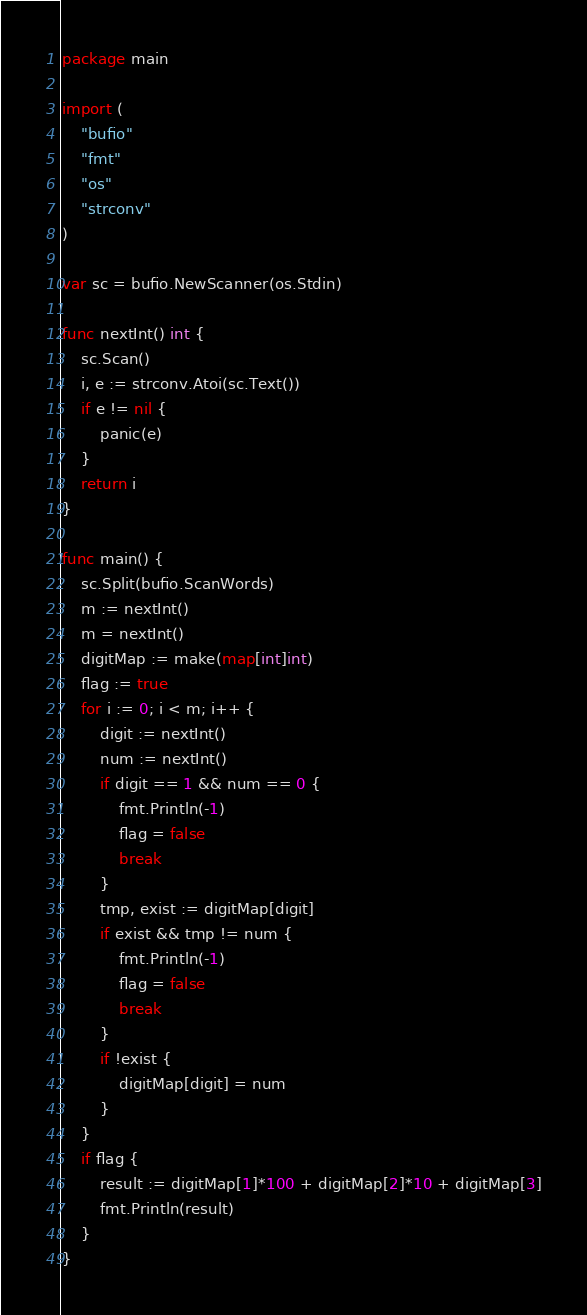<code> <loc_0><loc_0><loc_500><loc_500><_Go_>package main

import (
	"bufio"
	"fmt"
	"os"
	"strconv"
)

var sc = bufio.NewScanner(os.Stdin)

func nextInt() int {
	sc.Scan()
	i, e := strconv.Atoi(sc.Text())
	if e != nil {
		panic(e)
	}
	return i
}

func main() {
	sc.Split(bufio.ScanWords)
	m := nextInt()
	m = nextInt()
	digitMap := make(map[int]int)
	flag := true
	for i := 0; i < m; i++ {
		digit := nextInt()
		num := nextInt()
		if digit == 1 && num == 0 {
			fmt.Println(-1)
			flag = false
			break
		}
		tmp, exist := digitMap[digit]
		if exist && tmp != num {
			fmt.Println(-1)
			flag = false
			break
		}
		if !exist {
			digitMap[digit] = num
		}
	}
	if flag {
		result := digitMap[1]*100 + digitMap[2]*10 + digitMap[3]
		fmt.Println(result)
	}
}</code> 